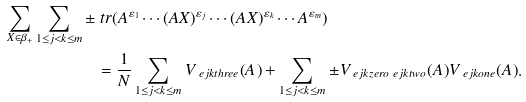Convert formula to latex. <formula><loc_0><loc_0><loc_500><loc_500>\sum _ { X \in \beta _ { + } } \sum _ { 1 \leq j < k \leq m } \pm & \ t r ( A ^ { \varepsilon _ { 1 } } \cdots ( A X ) ^ { \varepsilon _ { j } } \cdots ( A X ) ^ { \varepsilon _ { k } } \cdots A ^ { \varepsilon _ { m } } ) \\ & = \frac { 1 } { N } \sum _ { 1 \leq j < k \leq m } V _ { \ e j k t h r e e } ( A ) + \sum _ { 1 \leq j < k \leq m } \pm V _ { \ e j k z e r o \ e j k t w o } ( A ) V _ { \ e j k o n e } ( A ) .</formula> 